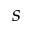<formula> <loc_0><loc_0><loc_500><loc_500>s</formula> 